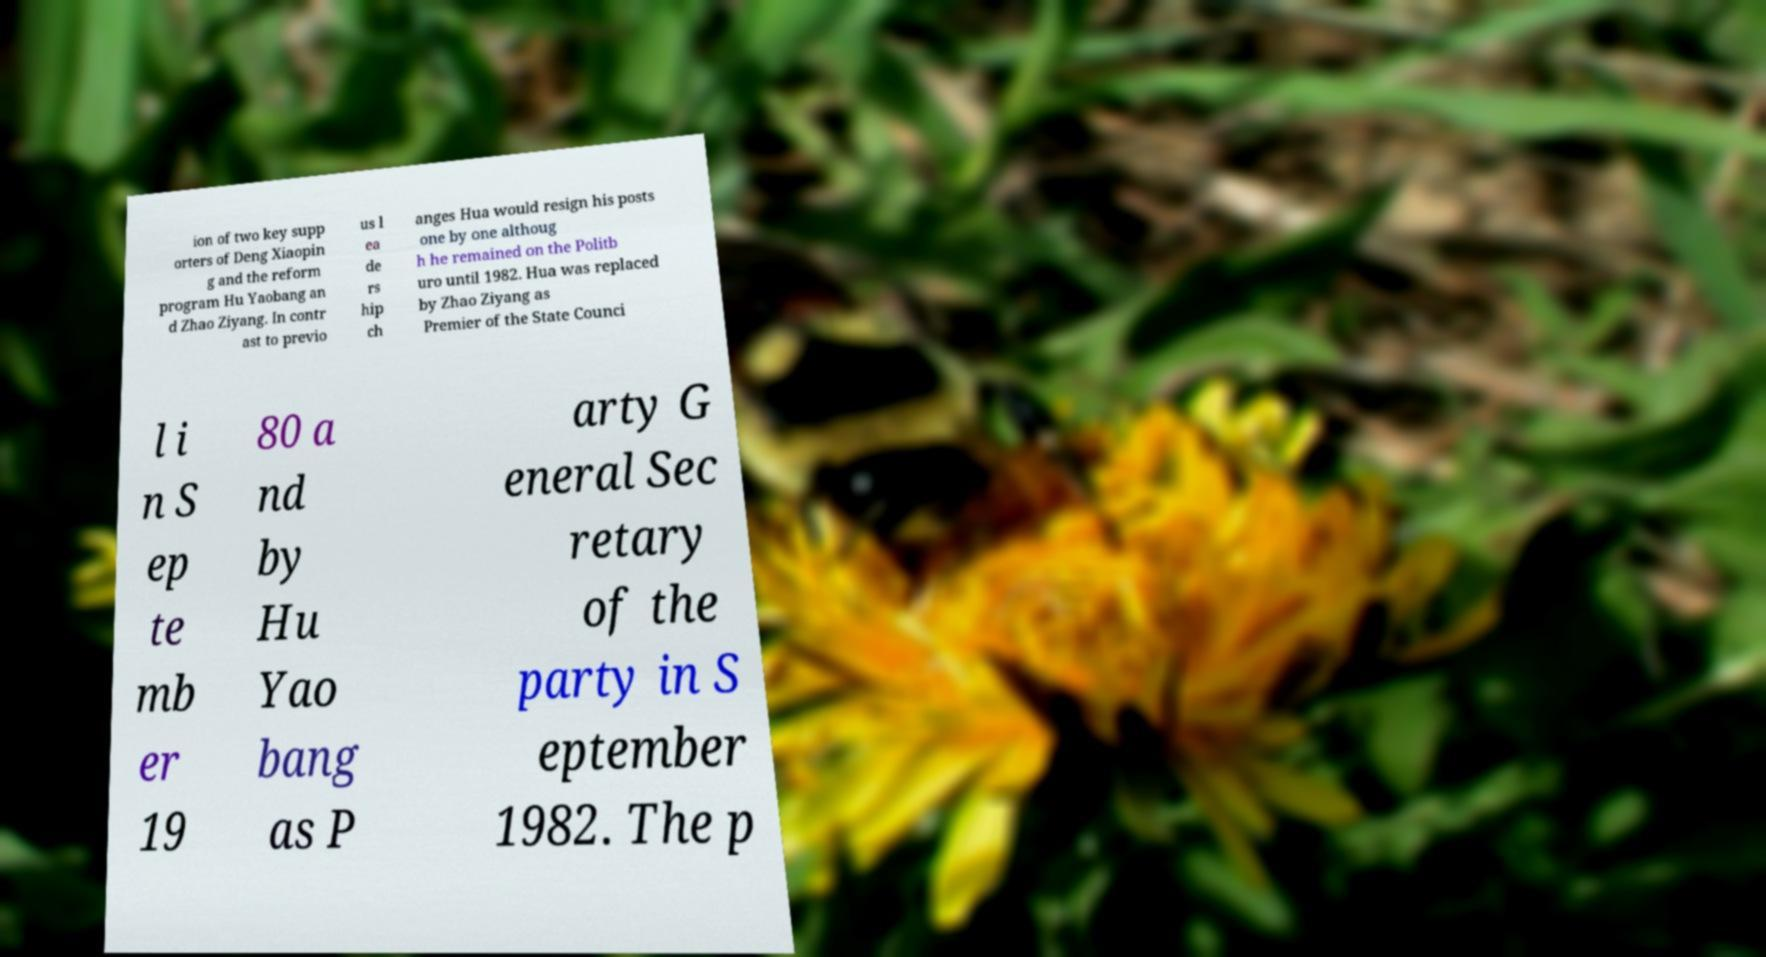There's text embedded in this image that I need extracted. Can you transcribe it verbatim? ion of two key supp orters of Deng Xiaopin g and the reform program Hu Yaobang an d Zhao Ziyang. In contr ast to previo us l ea de rs hip ch anges Hua would resign his posts one by one althoug h he remained on the Politb uro until 1982. Hua was replaced by Zhao Ziyang as Premier of the State Counci l i n S ep te mb er 19 80 a nd by Hu Yao bang as P arty G eneral Sec retary of the party in S eptember 1982. The p 